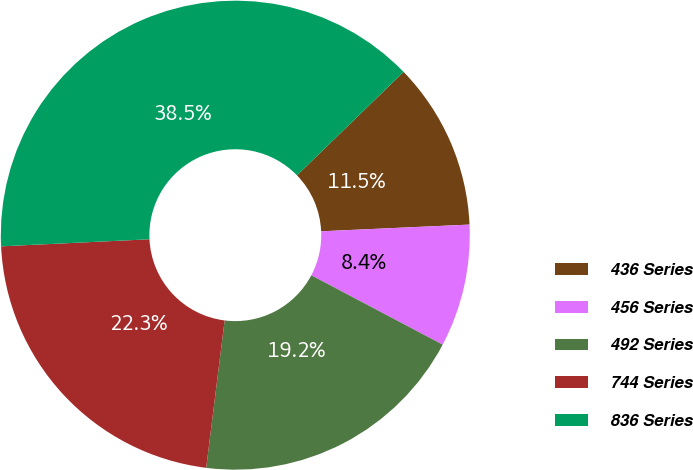Convert chart to OTSL. <chart><loc_0><loc_0><loc_500><loc_500><pie_chart><fcel>436 Series<fcel>456 Series<fcel>492 Series<fcel>744 Series<fcel>836 Series<nl><fcel>11.54%<fcel>8.45%<fcel>19.25%<fcel>22.26%<fcel>38.5%<nl></chart> 